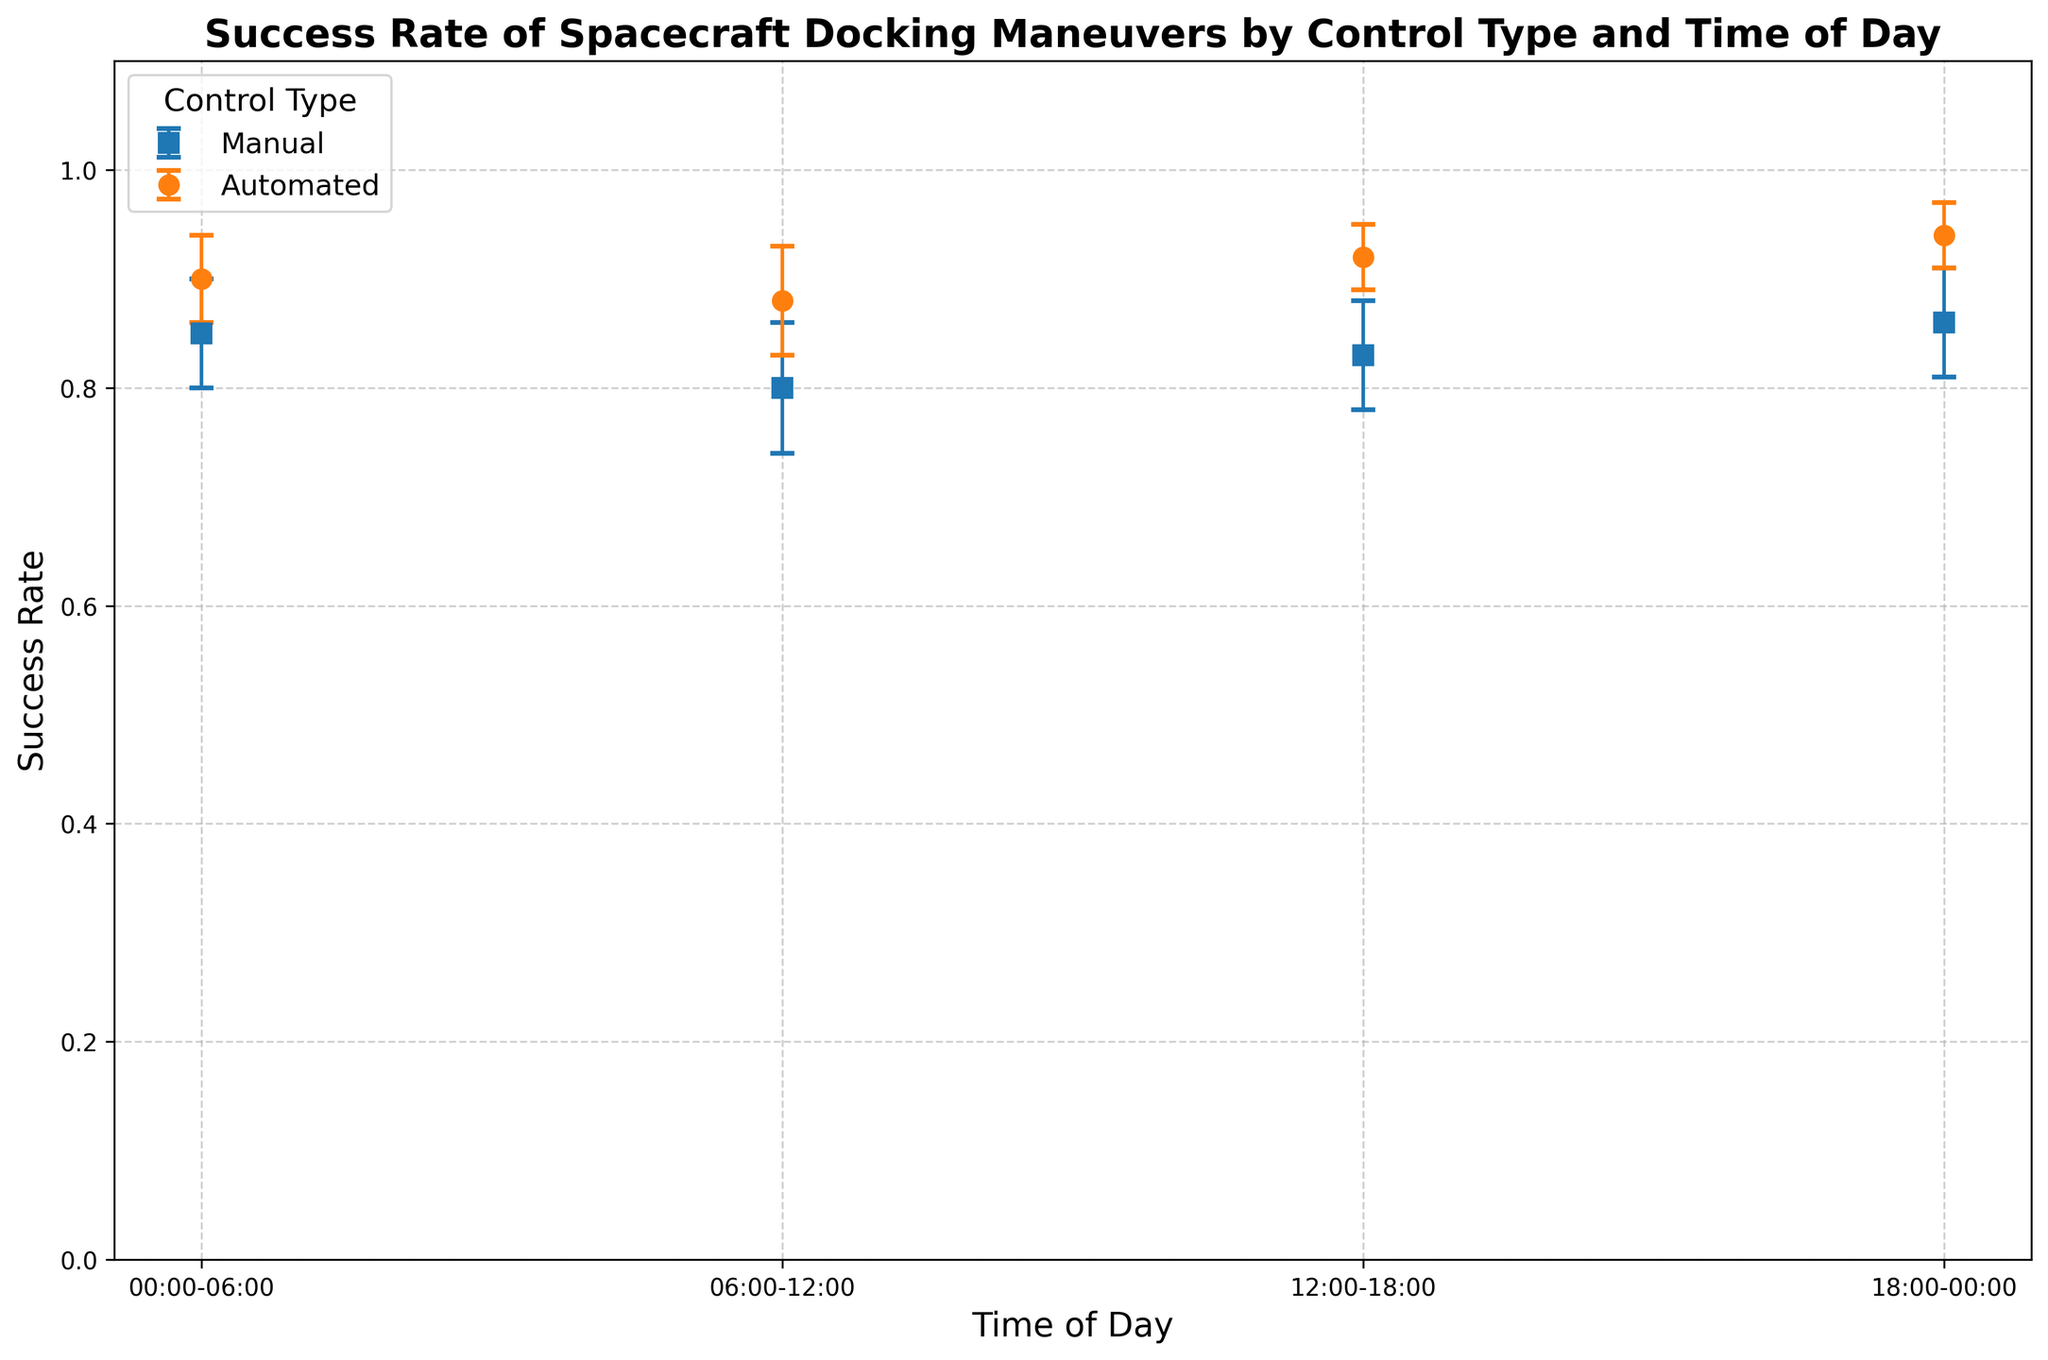What time of day has the highest success rate for automated docking maneuvers? Looking at the automated controls data points, the highest success rate is visible in the period 18:00-00:00.
Answer: 18:00-00:00 How does the success rate of manual control at 06:00-12:00 compare to that of automated control at the same time? The success rate for manual control at 06:00-12:00 is 0.80, while for automated control it is 0.88. Automated control has a higher success rate in this time period.
Answer: Automated control has a higher success rate Which control type shows less variation in success rates throughout the day? By observing the error margins for each time period, automated control consistently has smaller error margins than manual control, indicating less variation.
Answer: Automated control Is there a time of day where the success rates for manual and automated controls are equal? None of the time periods have equal success rates for both manual and automated controls based on the plotted data.
Answer: No Between 12:00-18:00 for manual controls, and 18:00-00:00 for automated controls, which has a higher success rate? The success rate for manual controls at 12:00-18:00 is 0.83, while for automated controls at 18:00-00:00 it is 0.94. Automated controls at 18:00-00:00 have a higher success rate.
Answer: Automated controls at 18:00-00:00 What is the average success rate for manual controls across all time periods? The success rates for manual controls are: 0.85, 0.80, 0.83, and 0.86. The average is calculated as (0.85 + 0.80 + 0.83 + 0.86) / 4 = 0.835.
Answer: 0.835 During which time period do manual controls have the smallest success rate? By comparing all the manual control data points, the period 06:00-12:00 has the smallest success rate of 0.80.
Answer: 06:00-12:00 If automated controls were used exclusively, what would be the overall success rate considering all time periods? The success rates for automated controls are: 0.90, 0.88, 0.92, and 0.94. The average is calculated as (0.90 + 0.88 + 0.92 + 0.94) / 4 = 0.91.
Answer: 0.91 